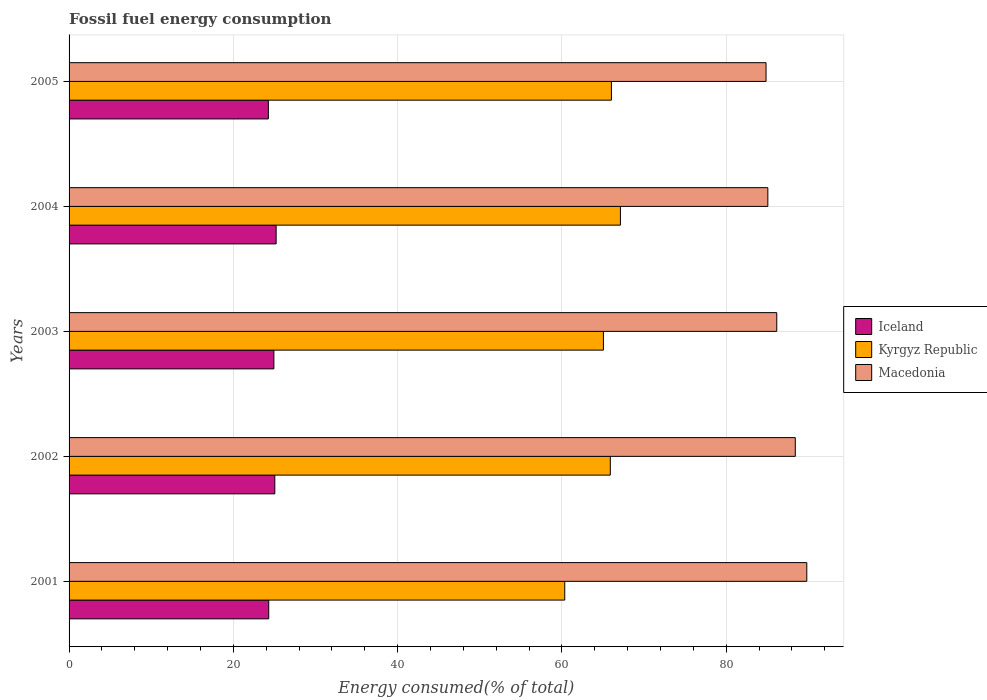How many different coloured bars are there?
Your answer should be compact. 3. Are the number of bars per tick equal to the number of legend labels?
Offer a terse response. Yes. How many bars are there on the 3rd tick from the top?
Provide a short and direct response. 3. How many bars are there on the 3rd tick from the bottom?
Provide a short and direct response. 3. What is the label of the 3rd group of bars from the top?
Offer a terse response. 2003. In how many cases, is the number of bars for a given year not equal to the number of legend labels?
Your answer should be very brief. 0. What is the percentage of energy consumed in Kyrgyz Republic in 2004?
Keep it short and to the point. 67.12. Across all years, what is the maximum percentage of energy consumed in Macedonia?
Provide a short and direct response. 89.81. Across all years, what is the minimum percentage of energy consumed in Macedonia?
Your answer should be compact. 84.85. In which year was the percentage of energy consumed in Iceland minimum?
Your answer should be compact. 2005. What is the total percentage of energy consumed in Macedonia in the graph?
Provide a succinct answer. 434.28. What is the difference between the percentage of energy consumed in Iceland in 2001 and that in 2002?
Make the answer very short. -0.74. What is the difference between the percentage of energy consumed in Iceland in 2001 and the percentage of energy consumed in Macedonia in 2003?
Offer a terse response. -61.85. What is the average percentage of energy consumed in Kyrgyz Republic per year?
Your answer should be very brief. 64.88. In the year 2004, what is the difference between the percentage of energy consumed in Iceland and percentage of energy consumed in Macedonia?
Your response must be concise. -59.86. What is the ratio of the percentage of energy consumed in Iceland in 2001 to that in 2003?
Offer a terse response. 0.97. What is the difference between the highest and the second highest percentage of energy consumed in Kyrgyz Republic?
Offer a terse response. 1.1. What is the difference between the highest and the lowest percentage of energy consumed in Kyrgyz Republic?
Make the answer very short. 6.78. Is the sum of the percentage of energy consumed in Macedonia in 2003 and 2005 greater than the maximum percentage of energy consumed in Kyrgyz Republic across all years?
Ensure brevity in your answer.  Yes. What does the 1st bar from the top in 2004 represents?
Provide a short and direct response. Macedonia. What does the 2nd bar from the bottom in 2001 represents?
Ensure brevity in your answer.  Kyrgyz Republic. Is it the case that in every year, the sum of the percentage of energy consumed in Kyrgyz Republic and percentage of energy consumed in Macedonia is greater than the percentage of energy consumed in Iceland?
Give a very brief answer. Yes. How many bars are there?
Provide a short and direct response. 15. Are all the bars in the graph horizontal?
Offer a terse response. Yes. Does the graph contain any zero values?
Your response must be concise. No. Does the graph contain grids?
Provide a short and direct response. Yes. Where does the legend appear in the graph?
Your answer should be compact. Center right. How are the legend labels stacked?
Offer a terse response. Vertical. What is the title of the graph?
Your response must be concise. Fossil fuel energy consumption. Does "Low & middle income" appear as one of the legend labels in the graph?
Ensure brevity in your answer.  No. What is the label or title of the X-axis?
Give a very brief answer. Energy consumed(% of total). What is the Energy consumed(% of total) of Iceland in 2001?
Your answer should be compact. 24.31. What is the Energy consumed(% of total) in Kyrgyz Republic in 2001?
Your response must be concise. 60.34. What is the Energy consumed(% of total) in Macedonia in 2001?
Offer a terse response. 89.81. What is the Energy consumed(% of total) in Iceland in 2002?
Provide a short and direct response. 25.05. What is the Energy consumed(% of total) of Kyrgyz Republic in 2002?
Ensure brevity in your answer.  65.89. What is the Energy consumed(% of total) in Macedonia in 2002?
Make the answer very short. 88.41. What is the Energy consumed(% of total) of Iceland in 2003?
Your answer should be very brief. 24.93. What is the Energy consumed(% of total) of Kyrgyz Republic in 2003?
Provide a short and direct response. 65.05. What is the Energy consumed(% of total) in Macedonia in 2003?
Your response must be concise. 86.15. What is the Energy consumed(% of total) in Iceland in 2004?
Ensure brevity in your answer.  25.21. What is the Energy consumed(% of total) in Kyrgyz Republic in 2004?
Ensure brevity in your answer.  67.12. What is the Energy consumed(% of total) of Macedonia in 2004?
Your answer should be very brief. 85.07. What is the Energy consumed(% of total) of Iceland in 2005?
Your response must be concise. 24.26. What is the Energy consumed(% of total) in Kyrgyz Republic in 2005?
Provide a short and direct response. 66.02. What is the Energy consumed(% of total) of Macedonia in 2005?
Your answer should be compact. 84.85. Across all years, what is the maximum Energy consumed(% of total) in Iceland?
Provide a short and direct response. 25.21. Across all years, what is the maximum Energy consumed(% of total) of Kyrgyz Republic?
Ensure brevity in your answer.  67.12. Across all years, what is the maximum Energy consumed(% of total) of Macedonia?
Provide a short and direct response. 89.81. Across all years, what is the minimum Energy consumed(% of total) in Iceland?
Give a very brief answer. 24.26. Across all years, what is the minimum Energy consumed(% of total) of Kyrgyz Republic?
Your answer should be compact. 60.34. Across all years, what is the minimum Energy consumed(% of total) of Macedonia?
Your answer should be compact. 84.85. What is the total Energy consumed(% of total) of Iceland in the graph?
Keep it short and to the point. 123.75. What is the total Energy consumed(% of total) of Kyrgyz Republic in the graph?
Keep it short and to the point. 324.42. What is the total Energy consumed(% of total) in Macedonia in the graph?
Provide a succinct answer. 434.28. What is the difference between the Energy consumed(% of total) in Iceland in 2001 and that in 2002?
Your answer should be compact. -0.74. What is the difference between the Energy consumed(% of total) of Kyrgyz Republic in 2001 and that in 2002?
Provide a short and direct response. -5.55. What is the difference between the Energy consumed(% of total) in Macedonia in 2001 and that in 2002?
Your answer should be compact. 1.4. What is the difference between the Energy consumed(% of total) of Iceland in 2001 and that in 2003?
Your response must be concise. -0.63. What is the difference between the Energy consumed(% of total) in Kyrgyz Republic in 2001 and that in 2003?
Offer a very short reply. -4.71. What is the difference between the Energy consumed(% of total) of Macedonia in 2001 and that in 2003?
Provide a short and direct response. 3.65. What is the difference between the Energy consumed(% of total) in Iceland in 2001 and that in 2004?
Ensure brevity in your answer.  -0.9. What is the difference between the Energy consumed(% of total) in Kyrgyz Republic in 2001 and that in 2004?
Your response must be concise. -6.78. What is the difference between the Energy consumed(% of total) of Macedonia in 2001 and that in 2004?
Your answer should be very brief. 4.74. What is the difference between the Energy consumed(% of total) in Iceland in 2001 and that in 2005?
Offer a very short reply. 0.05. What is the difference between the Energy consumed(% of total) of Kyrgyz Republic in 2001 and that in 2005?
Your answer should be compact. -5.68. What is the difference between the Energy consumed(% of total) of Macedonia in 2001 and that in 2005?
Offer a terse response. 4.96. What is the difference between the Energy consumed(% of total) in Iceland in 2002 and that in 2003?
Keep it short and to the point. 0.11. What is the difference between the Energy consumed(% of total) in Kyrgyz Republic in 2002 and that in 2003?
Keep it short and to the point. 0.84. What is the difference between the Energy consumed(% of total) in Macedonia in 2002 and that in 2003?
Your answer should be compact. 2.26. What is the difference between the Energy consumed(% of total) in Iceland in 2002 and that in 2004?
Your response must be concise. -0.16. What is the difference between the Energy consumed(% of total) of Kyrgyz Republic in 2002 and that in 2004?
Offer a terse response. -1.23. What is the difference between the Energy consumed(% of total) of Macedonia in 2002 and that in 2004?
Your answer should be compact. 3.34. What is the difference between the Energy consumed(% of total) of Iceland in 2002 and that in 2005?
Your response must be concise. 0.79. What is the difference between the Energy consumed(% of total) in Kyrgyz Republic in 2002 and that in 2005?
Keep it short and to the point. -0.13. What is the difference between the Energy consumed(% of total) in Macedonia in 2002 and that in 2005?
Give a very brief answer. 3.56. What is the difference between the Energy consumed(% of total) in Iceland in 2003 and that in 2004?
Your answer should be very brief. -0.27. What is the difference between the Energy consumed(% of total) in Kyrgyz Republic in 2003 and that in 2004?
Provide a succinct answer. -2.07. What is the difference between the Energy consumed(% of total) in Macedonia in 2003 and that in 2004?
Your answer should be compact. 1.09. What is the difference between the Energy consumed(% of total) of Iceland in 2003 and that in 2005?
Provide a succinct answer. 0.67. What is the difference between the Energy consumed(% of total) of Kyrgyz Republic in 2003 and that in 2005?
Keep it short and to the point. -0.97. What is the difference between the Energy consumed(% of total) of Macedonia in 2003 and that in 2005?
Give a very brief answer. 1.31. What is the difference between the Energy consumed(% of total) in Iceland in 2004 and that in 2005?
Your answer should be compact. 0.95. What is the difference between the Energy consumed(% of total) of Kyrgyz Republic in 2004 and that in 2005?
Ensure brevity in your answer.  1.1. What is the difference between the Energy consumed(% of total) of Macedonia in 2004 and that in 2005?
Your response must be concise. 0.22. What is the difference between the Energy consumed(% of total) in Iceland in 2001 and the Energy consumed(% of total) in Kyrgyz Republic in 2002?
Give a very brief answer. -41.58. What is the difference between the Energy consumed(% of total) in Iceland in 2001 and the Energy consumed(% of total) in Macedonia in 2002?
Give a very brief answer. -64.1. What is the difference between the Energy consumed(% of total) of Kyrgyz Republic in 2001 and the Energy consumed(% of total) of Macedonia in 2002?
Your response must be concise. -28.07. What is the difference between the Energy consumed(% of total) in Iceland in 2001 and the Energy consumed(% of total) in Kyrgyz Republic in 2003?
Your answer should be compact. -40.74. What is the difference between the Energy consumed(% of total) of Iceland in 2001 and the Energy consumed(% of total) of Macedonia in 2003?
Offer a terse response. -61.85. What is the difference between the Energy consumed(% of total) of Kyrgyz Republic in 2001 and the Energy consumed(% of total) of Macedonia in 2003?
Your response must be concise. -25.81. What is the difference between the Energy consumed(% of total) in Iceland in 2001 and the Energy consumed(% of total) in Kyrgyz Republic in 2004?
Your answer should be very brief. -42.81. What is the difference between the Energy consumed(% of total) of Iceland in 2001 and the Energy consumed(% of total) of Macedonia in 2004?
Make the answer very short. -60.76. What is the difference between the Energy consumed(% of total) in Kyrgyz Republic in 2001 and the Energy consumed(% of total) in Macedonia in 2004?
Your answer should be very brief. -24.72. What is the difference between the Energy consumed(% of total) in Iceland in 2001 and the Energy consumed(% of total) in Kyrgyz Republic in 2005?
Give a very brief answer. -41.72. What is the difference between the Energy consumed(% of total) in Iceland in 2001 and the Energy consumed(% of total) in Macedonia in 2005?
Ensure brevity in your answer.  -60.54. What is the difference between the Energy consumed(% of total) of Kyrgyz Republic in 2001 and the Energy consumed(% of total) of Macedonia in 2005?
Your answer should be very brief. -24.5. What is the difference between the Energy consumed(% of total) in Iceland in 2002 and the Energy consumed(% of total) in Kyrgyz Republic in 2003?
Your response must be concise. -40. What is the difference between the Energy consumed(% of total) in Iceland in 2002 and the Energy consumed(% of total) in Macedonia in 2003?
Your answer should be very brief. -61.11. What is the difference between the Energy consumed(% of total) in Kyrgyz Republic in 2002 and the Energy consumed(% of total) in Macedonia in 2003?
Offer a terse response. -20.26. What is the difference between the Energy consumed(% of total) in Iceland in 2002 and the Energy consumed(% of total) in Kyrgyz Republic in 2004?
Give a very brief answer. -42.07. What is the difference between the Energy consumed(% of total) in Iceland in 2002 and the Energy consumed(% of total) in Macedonia in 2004?
Your response must be concise. -60.02. What is the difference between the Energy consumed(% of total) of Kyrgyz Republic in 2002 and the Energy consumed(% of total) of Macedonia in 2004?
Offer a very short reply. -19.18. What is the difference between the Energy consumed(% of total) in Iceland in 2002 and the Energy consumed(% of total) in Kyrgyz Republic in 2005?
Ensure brevity in your answer.  -40.98. What is the difference between the Energy consumed(% of total) in Iceland in 2002 and the Energy consumed(% of total) in Macedonia in 2005?
Keep it short and to the point. -59.8. What is the difference between the Energy consumed(% of total) in Kyrgyz Republic in 2002 and the Energy consumed(% of total) in Macedonia in 2005?
Offer a very short reply. -18.96. What is the difference between the Energy consumed(% of total) in Iceland in 2003 and the Energy consumed(% of total) in Kyrgyz Republic in 2004?
Ensure brevity in your answer.  -42.19. What is the difference between the Energy consumed(% of total) of Iceland in 2003 and the Energy consumed(% of total) of Macedonia in 2004?
Offer a very short reply. -60.13. What is the difference between the Energy consumed(% of total) in Kyrgyz Republic in 2003 and the Energy consumed(% of total) in Macedonia in 2004?
Make the answer very short. -20.02. What is the difference between the Energy consumed(% of total) of Iceland in 2003 and the Energy consumed(% of total) of Kyrgyz Republic in 2005?
Your answer should be very brief. -41.09. What is the difference between the Energy consumed(% of total) in Iceland in 2003 and the Energy consumed(% of total) in Macedonia in 2005?
Offer a very short reply. -59.91. What is the difference between the Energy consumed(% of total) in Kyrgyz Republic in 2003 and the Energy consumed(% of total) in Macedonia in 2005?
Offer a terse response. -19.8. What is the difference between the Energy consumed(% of total) in Iceland in 2004 and the Energy consumed(% of total) in Kyrgyz Republic in 2005?
Ensure brevity in your answer.  -40.82. What is the difference between the Energy consumed(% of total) in Iceland in 2004 and the Energy consumed(% of total) in Macedonia in 2005?
Keep it short and to the point. -59.64. What is the difference between the Energy consumed(% of total) in Kyrgyz Republic in 2004 and the Energy consumed(% of total) in Macedonia in 2005?
Ensure brevity in your answer.  -17.73. What is the average Energy consumed(% of total) of Iceland per year?
Make the answer very short. 24.75. What is the average Energy consumed(% of total) of Kyrgyz Republic per year?
Provide a short and direct response. 64.88. What is the average Energy consumed(% of total) in Macedonia per year?
Your response must be concise. 86.86. In the year 2001, what is the difference between the Energy consumed(% of total) in Iceland and Energy consumed(% of total) in Kyrgyz Republic?
Offer a terse response. -36.04. In the year 2001, what is the difference between the Energy consumed(% of total) in Iceland and Energy consumed(% of total) in Macedonia?
Offer a very short reply. -65.5. In the year 2001, what is the difference between the Energy consumed(% of total) in Kyrgyz Republic and Energy consumed(% of total) in Macedonia?
Make the answer very short. -29.46. In the year 2002, what is the difference between the Energy consumed(% of total) in Iceland and Energy consumed(% of total) in Kyrgyz Republic?
Keep it short and to the point. -40.84. In the year 2002, what is the difference between the Energy consumed(% of total) of Iceland and Energy consumed(% of total) of Macedonia?
Ensure brevity in your answer.  -63.36. In the year 2002, what is the difference between the Energy consumed(% of total) of Kyrgyz Republic and Energy consumed(% of total) of Macedonia?
Ensure brevity in your answer.  -22.52. In the year 2003, what is the difference between the Energy consumed(% of total) of Iceland and Energy consumed(% of total) of Kyrgyz Republic?
Ensure brevity in your answer.  -40.12. In the year 2003, what is the difference between the Energy consumed(% of total) of Iceland and Energy consumed(% of total) of Macedonia?
Provide a succinct answer. -61.22. In the year 2003, what is the difference between the Energy consumed(% of total) of Kyrgyz Republic and Energy consumed(% of total) of Macedonia?
Your response must be concise. -21.1. In the year 2004, what is the difference between the Energy consumed(% of total) of Iceland and Energy consumed(% of total) of Kyrgyz Republic?
Provide a short and direct response. -41.91. In the year 2004, what is the difference between the Energy consumed(% of total) of Iceland and Energy consumed(% of total) of Macedonia?
Your answer should be compact. -59.86. In the year 2004, what is the difference between the Energy consumed(% of total) in Kyrgyz Republic and Energy consumed(% of total) in Macedonia?
Your response must be concise. -17.95. In the year 2005, what is the difference between the Energy consumed(% of total) in Iceland and Energy consumed(% of total) in Kyrgyz Republic?
Keep it short and to the point. -41.76. In the year 2005, what is the difference between the Energy consumed(% of total) of Iceland and Energy consumed(% of total) of Macedonia?
Your answer should be compact. -60.59. In the year 2005, what is the difference between the Energy consumed(% of total) in Kyrgyz Republic and Energy consumed(% of total) in Macedonia?
Ensure brevity in your answer.  -18.82. What is the ratio of the Energy consumed(% of total) in Iceland in 2001 to that in 2002?
Ensure brevity in your answer.  0.97. What is the ratio of the Energy consumed(% of total) in Kyrgyz Republic in 2001 to that in 2002?
Provide a short and direct response. 0.92. What is the ratio of the Energy consumed(% of total) of Macedonia in 2001 to that in 2002?
Provide a short and direct response. 1.02. What is the ratio of the Energy consumed(% of total) in Iceland in 2001 to that in 2003?
Offer a terse response. 0.97. What is the ratio of the Energy consumed(% of total) of Kyrgyz Republic in 2001 to that in 2003?
Offer a terse response. 0.93. What is the ratio of the Energy consumed(% of total) in Macedonia in 2001 to that in 2003?
Your response must be concise. 1.04. What is the ratio of the Energy consumed(% of total) of Iceland in 2001 to that in 2004?
Ensure brevity in your answer.  0.96. What is the ratio of the Energy consumed(% of total) of Kyrgyz Republic in 2001 to that in 2004?
Provide a succinct answer. 0.9. What is the ratio of the Energy consumed(% of total) of Macedonia in 2001 to that in 2004?
Make the answer very short. 1.06. What is the ratio of the Energy consumed(% of total) of Iceland in 2001 to that in 2005?
Offer a terse response. 1. What is the ratio of the Energy consumed(% of total) in Kyrgyz Republic in 2001 to that in 2005?
Make the answer very short. 0.91. What is the ratio of the Energy consumed(% of total) in Macedonia in 2001 to that in 2005?
Make the answer very short. 1.06. What is the ratio of the Energy consumed(% of total) of Iceland in 2002 to that in 2003?
Your answer should be compact. 1. What is the ratio of the Energy consumed(% of total) in Kyrgyz Republic in 2002 to that in 2003?
Make the answer very short. 1.01. What is the ratio of the Energy consumed(% of total) of Macedonia in 2002 to that in 2003?
Provide a succinct answer. 1.03. What is the ratio of the Energy consumed(% of total) in Iceland in 2002 to that in 2004?
Keep it short and to the point. 0.99. What is the ratio of the Energy consumed(% of total) in Kyrgyz Republic in 2002 to that in 2004?
Make the answer very short. 0.98. What is the ratio of the Energy consumed(% of total) in Macedonia in 2002 to that in 2004?
Ensure brevity in your answer.  1.04. What is the ratio of the Energy consumed(% of total) in Iceland in 2002 to that in 2005?
Your response must be concise. 1.03. What is the ratio of the Energy consumed(% of total) in Kyrgyz Republic in 2002 to that in 2005?
Ensure brevity in your answer.  1. What is the ratio of the Energy consumed(% of total) in Macedonia in 2002 to that in 2005?
Provide a short and direct response. 1.04. What is the ratio of the Energy consumed(% of total) of Kyrgyz Republic in 2003 to that in 2004?
Give a very brief answer. 0.97. What is the ratio of the Energy consumed(% of total) in Macedonia in 2003 to that in 2004?
Offer a very short reply. 1.01. What is the ratio of the Energy consumed(% of total) in Iceland in 2003 to that in 2005?
Offer a terse response. 1.03. What is the ratio of the Energy consumed(% of total) in Macedonia in 2003 to that in 2005?
Make the answer very short. 1.02. What is the ratio of the Energy consumed(% of total) of Iceland in 2004 to that in 2005?
Your response must be concise. 1.04. What is the ratio of the Energy consumed(% of total) of Kyrgyz Republic in 2004 to that in 2005?
Ensure brevity in your answer.  1.02. What is the difference between the highest and the second highest Energy consumed(% of total) of Iceland?
Provide a short and direct response. 0.16. What is the difference between the highest and the second highest Energy consumed(% of total) in Kyrgyz Republic?
Keep it short and to the point. 1.1. What is the difference between the highest and the second highest Energy consumed(% of total) in Macedonia?
Provide a short and direct response. 1.4. What is the difference between the highest and the lowest Energy consumed(% of total) in Iceland?
Offer a terse response. 0.95. What is the difference between the highest and the lowest Energy consumed(% of total) in Kyrgyz Republic?
Offer a very short reply. 6.78. What is the difference between the highest and the lowest Energy consumed(% of total) in Macedonia?
Make the answer very short. 4.96. 